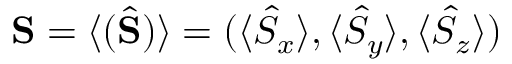<formula> <loc_0><loc_0><loc_500><loc_500>{ S } = \langle ( \hat { S } ) \rangle = ( \langle \hat { S } _ { x } \rangle , \langle \hat { S } _ { y } \rangle , \langle \hat { S } _ { z } \rangle )</formula> 